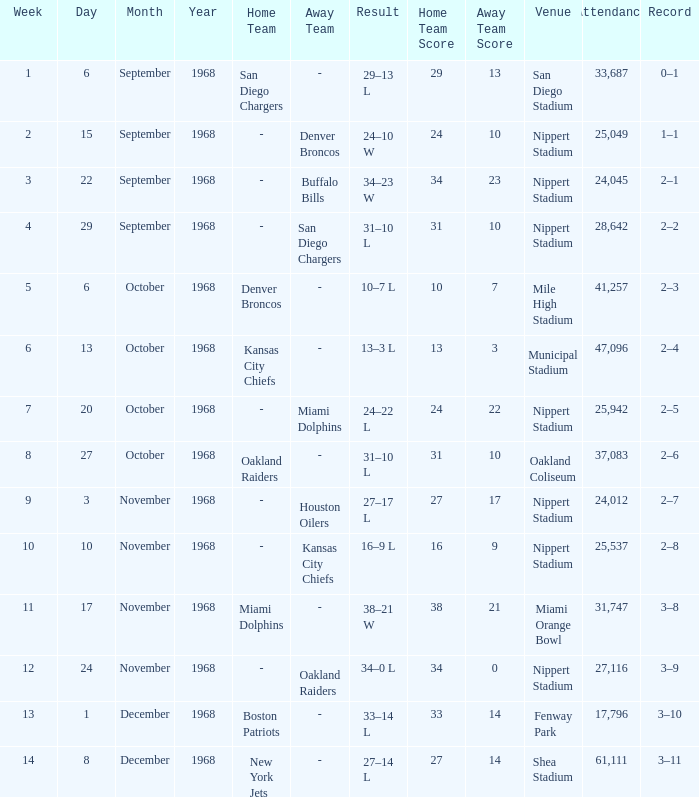What week was the game played at Mile High Stadium? 5.0. 